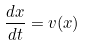Convert formula to latex. <formula><loc_0><loc_0><loc_500><loc_500>\frac { d x } { d t } = v ( x )</formula> 